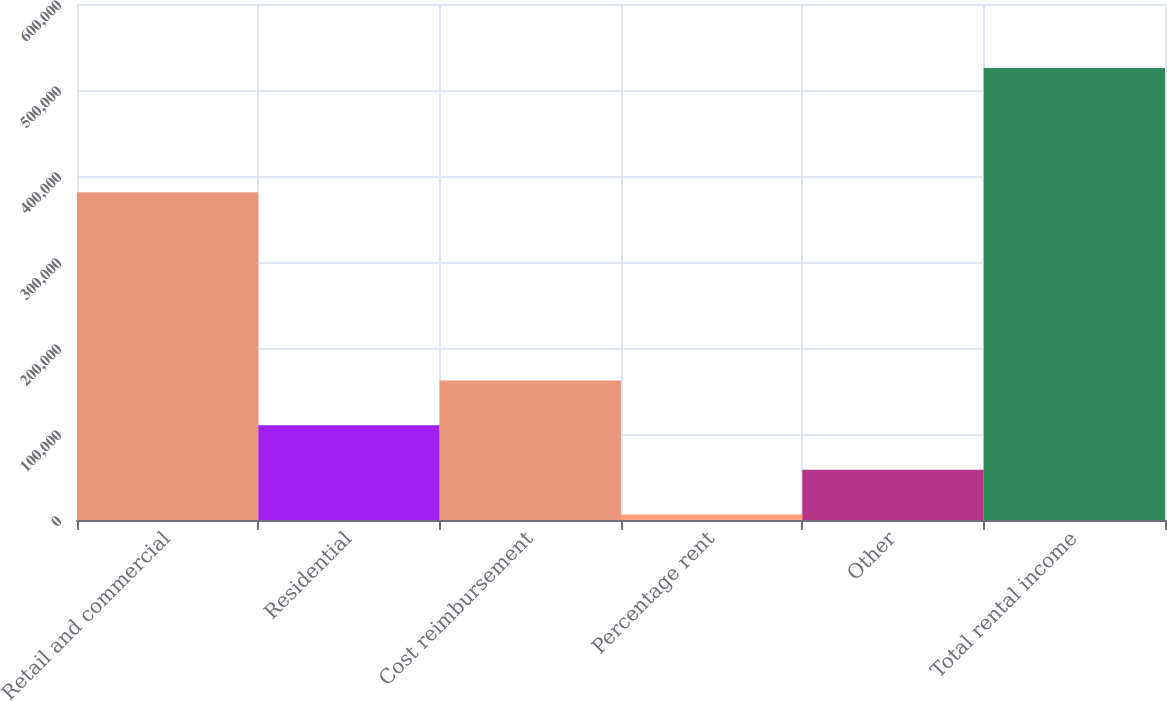Convert chart to OTSL. <chart><loc_0><loc_0><loc_500><loc_500><bar_chart><fcel>Retail and commercial<fcel>Residential<fcel>Cost reimbursement<fcel>Percentage rent<fcel>Other<fcel>Total rental income<nl><fcel>381012<fcel>110205<fcel>162120<fcel>6374<fcel>58289.4<fcel>525528<nl></chart> 